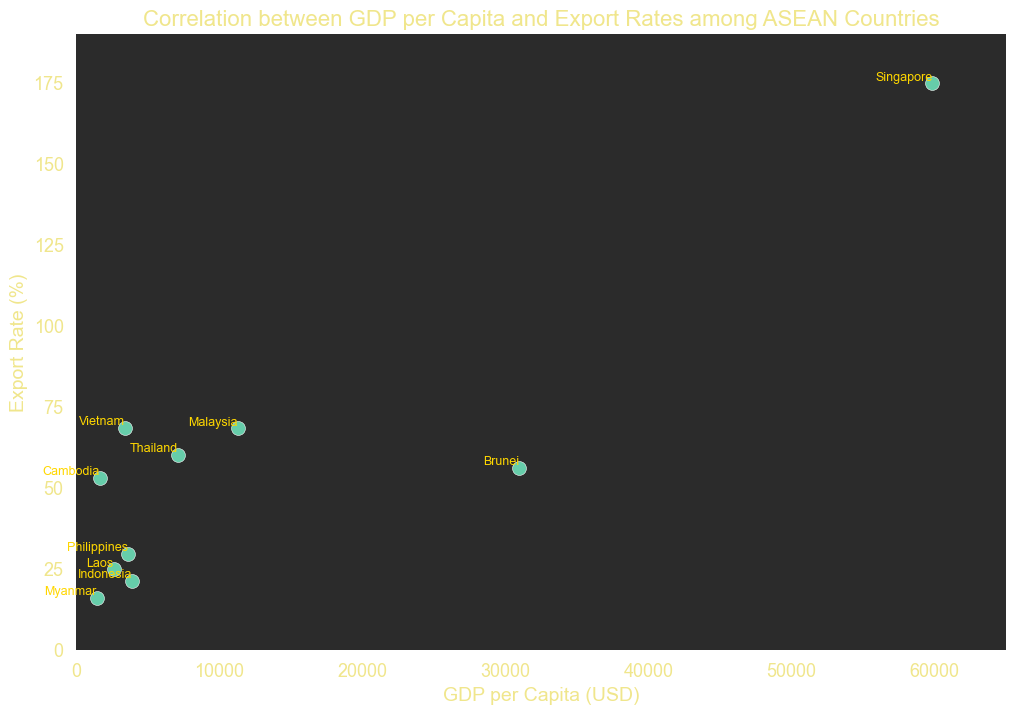What is the country with the highest GDP per capita? To answer this question, look at the horizontal axis and locate the point farthest to the right. The country label for that point is Singapore.
Answer: Singapore Which country has the highest export rate? To find the answer, look for the point that is highest on the vertical axis. The country label for this point is Singapore.
Answer: Singapore What is the relationship between GDP per capita and export rates among ASEAN countries as shown in the scatter plot? To determine the relationship, observe the overall trend in the scatter plot. Countries with higher GDP per capita also tend to have higher export rates, but there are exceptions.
Answer: Positive correlation with exceptions How many countries have a GDP per capita below 10,000 USD? Identify the points on the horizontal axis with values below 10,000 USD and count them. These countries are Cambodia, Indonesia, Laos, Myanmar, Philippines, and Vietnam, totaling 6 countries.
Answer: 6 Which two countries have the closest GDP per capita and what are their values? To find this, look for points that are horizontally close to each other. Laos and Cambodia have GDP per capita values of 2606 and 1629 respectively.
Answer: Laos and Cambodia (2606, 1629) Which country has the lowest export rate and what is its GDP per capita? To find this, look for the point that is lowest on the vertical axis. This country is Myanmar, which has an export rate of 16.1% and a GDP per capita of 1427 USD.
Answer: Myanmar, 1427 USD Among the countries with GDP per capita above 30,000 USD, which one has the lower export rate and what is it? For GDP per capita greater than 30,000 USD, examine Brunei and Singapore. Brunei has an export rate of 56.2%, which is lower than Singapore's 174.8%.
Answer: Brunei, 56.2% What is the difference in export rates between Malaysia and Thailand? Locate the export rates for Malaysia and Thailand on the vertical axis (68.4% and 60.2%, respectively). Subtract the smaller export rate (Thailand) from the larger export rate (Malaysia). The difference is 68.4% - 60.2% = 8.2%.
Answer: 8.2% Which country, among those with GDP per capita below 4000 USD, has the highest export rate? For countries with GDP per capita less than 4000 USD, identify the point with the highest vertical position. Vietnam has the highest export rate of 68.5%.
Answer: Vietnam What is the combined export rate of Singapore and Malaysia? Add the export rates of Singapore (174.8%) and Malaysia (68.4%) together. The combined export rate is 174.8% + 68.4% = 243.2%.
Answer: 243.2% 